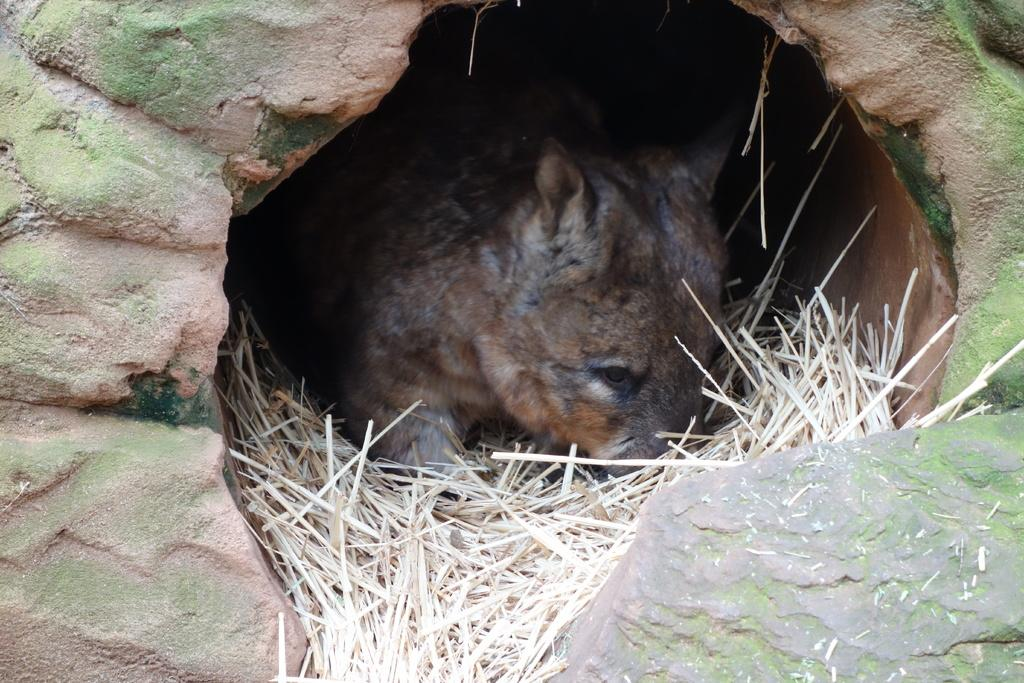What type of animal can be seen in the image? There is an animal in the image, but we cannot determine the specific type without more information. What type of vegetation is present in the image? Dried grass is present in the image. How many kittens are sitting on the furniture in the image? There is no furniture or kittens present in the image. What is the level of hope depicted in the image? The image does not convey a sense of hope or any emotions; it only shows an animal and dried grass. 